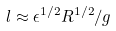Convert formula to latex. <formula><loc_0><loc_0><loc_500><loc_500>l \approx \epsilon ^ { 1 / 2 } R ^ { 1 / 2 } / g</formula> 